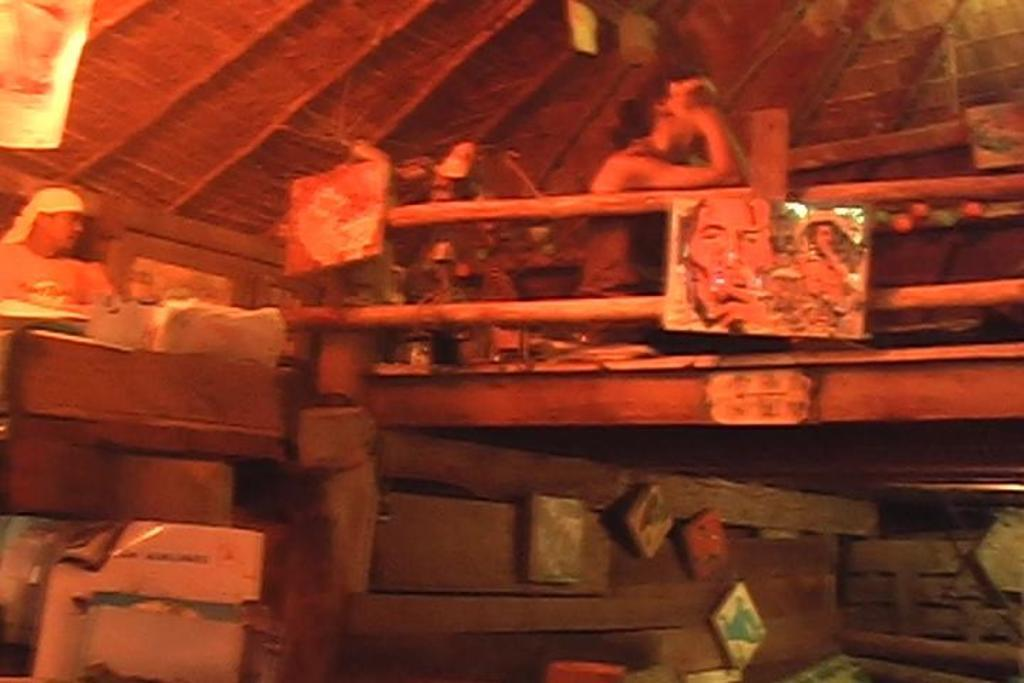Who or what can be seen in the image? There are people in the image. What type of object is present in the image that typically holds a photograph? There is a photo frame in the image. What kind of decorative item is visible in the image? There is a poster in the image. What material is used for some of the objects in the image? There are wooden objects in the image. Can you describe any other objects present in the image? There are other objects in the image, but their specific details are not mentioned in the provided facts. What can be seen in the background of the image? There is a roof visible in the background of the image. What type of berry is being picked by the people in the image? There is no mention of berries or people picking berries in the image. 